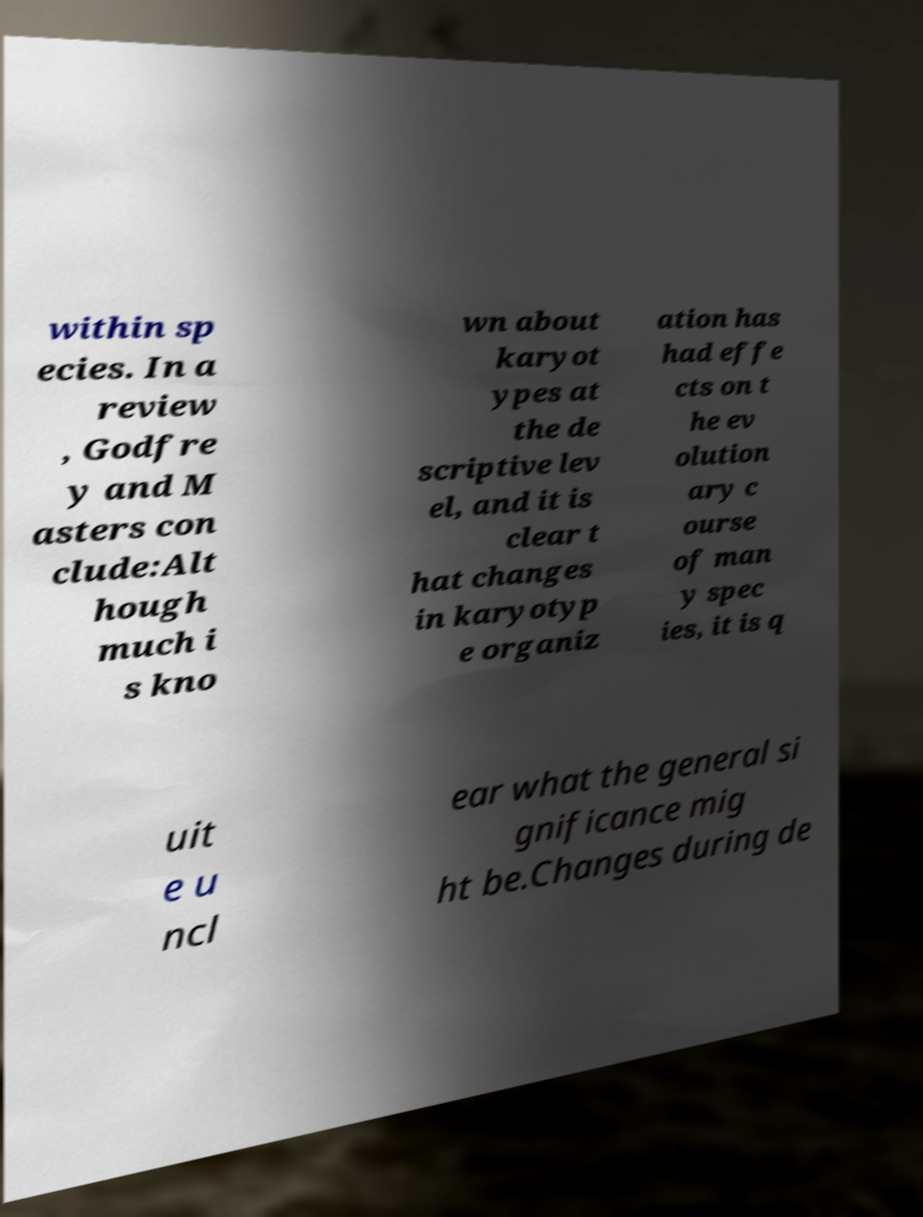Could you extract and type out the text from this image? within sp ecies. In a review , Godfre y and M asters con clude:Alt hough much i s kno wn about karyot ypes at the de scriptive lev el, and it is clear t hat changes in karyotyp e organiz ation has had effe cts on t he ev olution ary c ourse of man y spec ies, it is q uit e u ncl ear what the general si gnificance mig ht be.Changes during de 